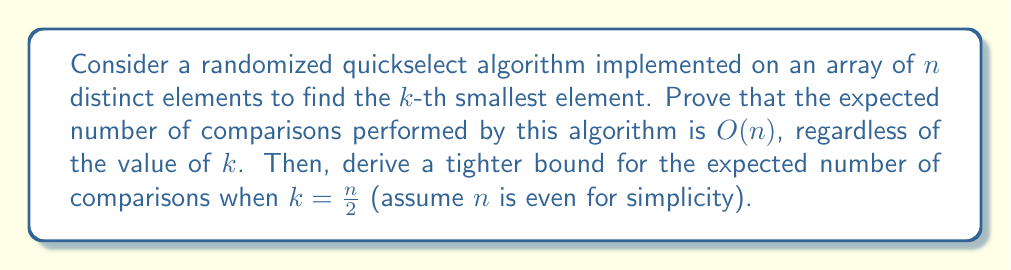Can you solve this math problem? Let's approach this problem step by step:

1) First, let's recall how randomized quickselect works:
   - It randomly selects a pivot element from the array.
   - It partitions the array around this pivot.
   - It then recursively applies the algorithm to the appropriate subarray.

2) Let $T(n)$ be the expected number of comparisons for an array of size $n$. We can write a recurrence relation:

   $$T(n) = n - 1 + \frac{1}{n}\sum_{i=1}^n T(i-1)$$

   This is because:
   - We always perform $n-1$ comparisons for the partitioning step.
   - The pivot can be any of the $n$ elements with equal probability $\frac{1}{n}$.
   - If the $i$-th element is chosen as pivot, we recurse on a subarray of size $i-1$.

3) To solve this recurrence, we can use the substitution method. Let's assume $T(n) \leq an$ for some constant $a$. Then:

   $$T(n) \leq n - 1 + \frac{1}{n}\sum_{i=1}^n a(i-1) = n - 1 + \frac{a}{n}\frac{n(n-1)}{2} = n - 1 + \frac{a(n-1)}{2}$$

4) For this to be $\leq an$, we need:

   $$n - 1 + \frac{a(n-1)}{2} \leq an$$
   $$n - 1 \leq an - \frac{a(n-1)}{2}$$
   $$n - 1 \leq \frac{an + a}{2}$$
   $$2n - 2 \leq an + a$$
   $$2n - a - 2 \leq an$$
   $$2n - 2 \leq (a+1)n$$

5) This inequality holds for $a \geq 3$. Therefore, $T(n) = O(n)$.

6) For a tighter bound when $k = \frac{n}{2}$, we can use the fact that the expected rank of the randomly chosen pivot is $\frac{n+1}{2}$. This means that, on average, we're reducing the problem size by half in each recursive call.

7) Let $S(n)$ be the expected number of comparisons for finding the median. We can write:

   $$S(n) = n - 1 + S(\frac{n}{2})$$

8) Solving this recurrence:

   $$S(n) = n - 1 + (\frac{n}{2} - 1) + (\frac{n}{4} - 1) + ... + 1$$
   $$S(n) = n + \frac{n}{2} + \frac{n}{4} + ... - \log_2 n$$
   $$S(n) = 2n - \log_2 n - 2$$

Therefore, the expected number of comparisons for finding the median is $2n - \log_2 n - 2$.
Answer: The expected number of comparisons in randomized quickselect is $O(n)$ for any $k$. For $k = \frac{n}{2}$ (finding the median), a tighter bound is $2n - \log_2 n - 2$ comparisons. 